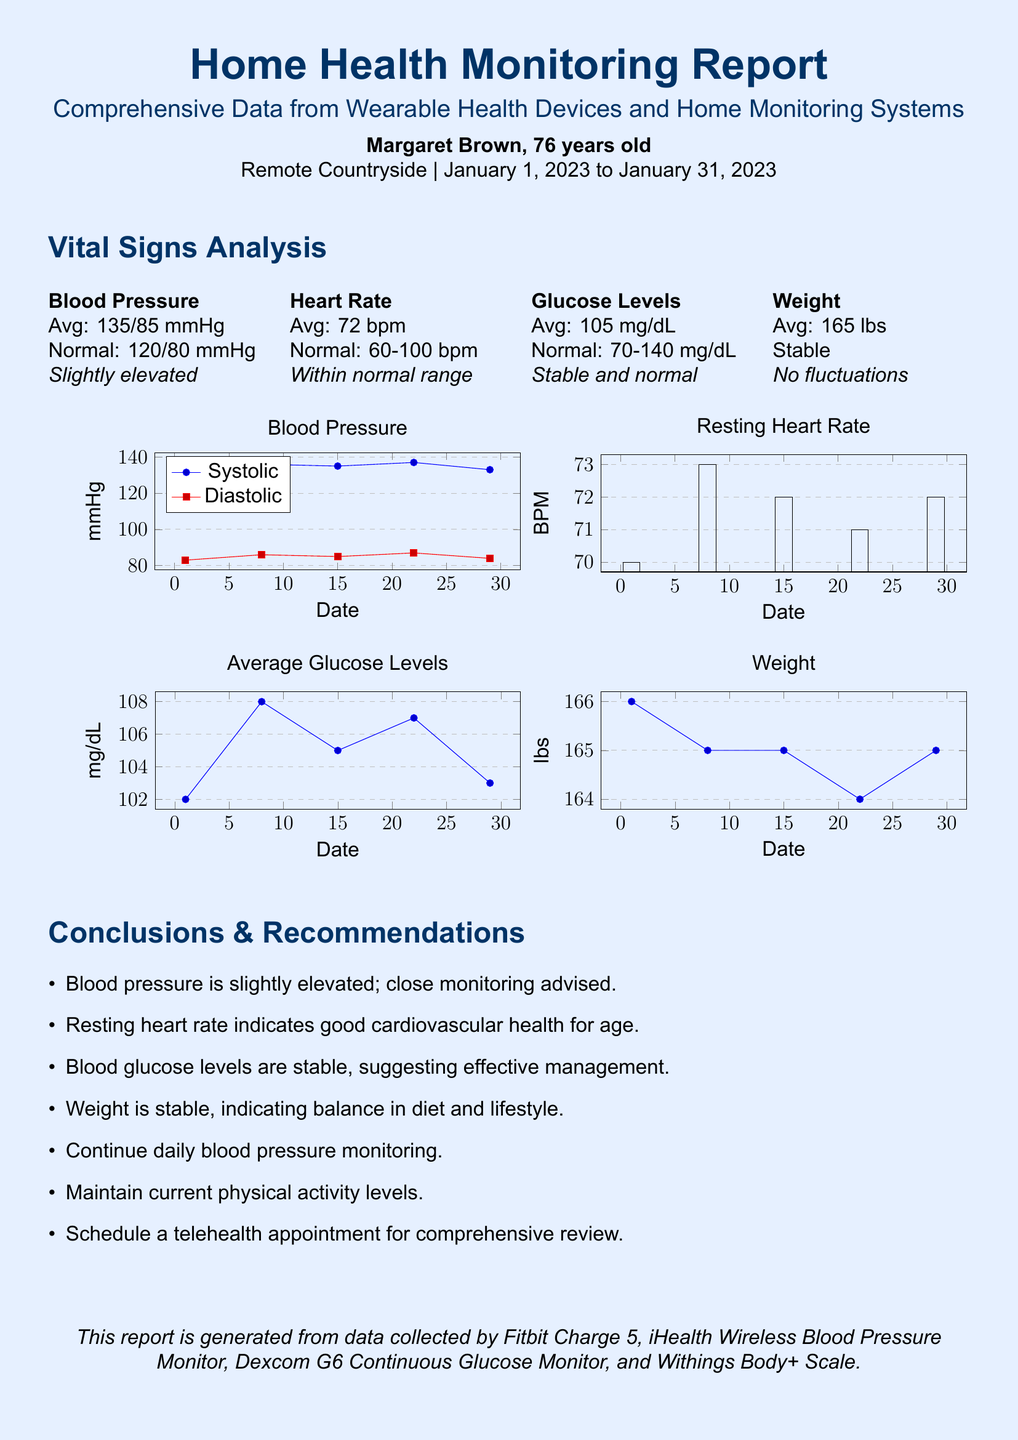what is the average blood pressure? The average blood pressure is noted in the vital signs analysis section of the document, which states 135/85 mmHg.
Answer: 135/85 mmHg what is the normal range for heart rate? The document specifies the normal range for heart rate as 60-100 bpm in the vital signs analysis section.
Answer: 60-100 bpm how many days does the report cover? The report spans from January 1, 2023, to January 31, 2023, indicating a total of 31 days.
Answer: 31 days what was the highest recorded blood pressure? The highest recorded systolic blood pressure in the graph is 137 mmHg on January 22.
Answer: 137 mmHg what is the recommendation for blood pressure monitoring? The recommendations section advises that close monitoring of blood pressure is advised due to its slight elevation.
Answer: Close monitoring how many different health metrics are analyzed in the report? The report analyzes four different health metrics: Blood Pressure, Heart Rate, Glucose Levels, and Weight as shown in the vital signs analysis section.
Answer: Four what is the average glucose level recorded? The average glucose level noted in the vital signs analysis section is 105 mg/dL.
Answer: 105 mg/dL what should be scheduled for a comprehensive review? The recommendations state that a telehealth appointment should be scheduled for a comprehensive review.
Answer: Telehealth appointment what is the average weight reported? The average weight reported in the vital signs analysis is 165 lbs.
Answer: 165 lbs 